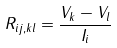<formula> <loc_0><loc_0><loc_500><loc_500>R _ { i j , k l } = \frac { V _ { k } - V _ { l } } { I _ { i } }</formula> 